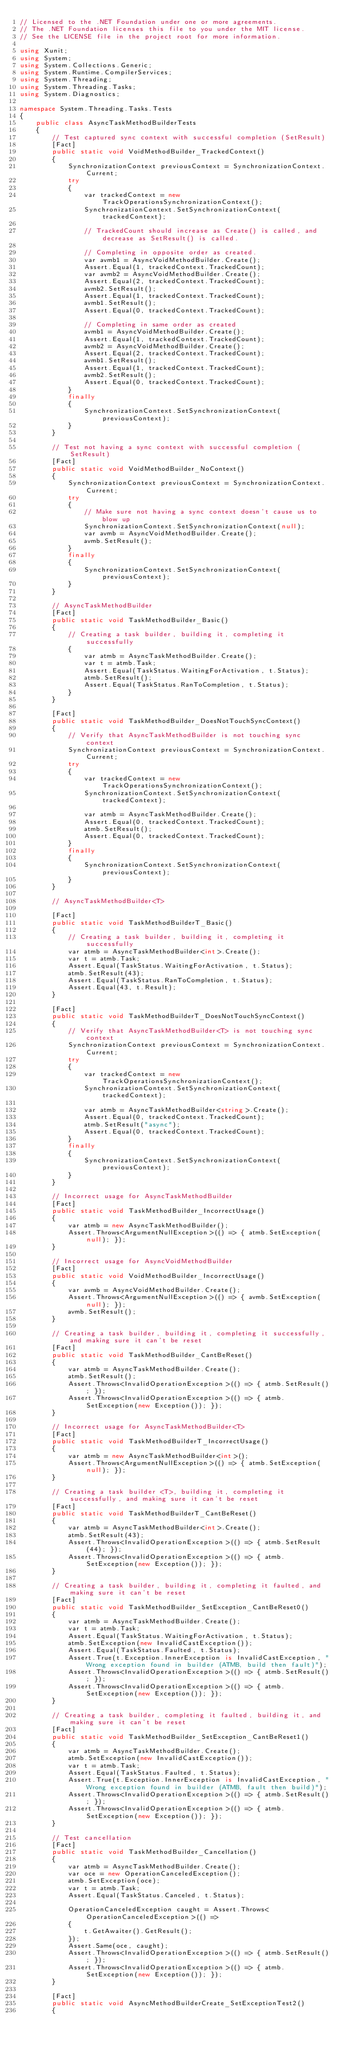Convert code to text. <code><loc_0><loc_0><loc_500><loc_500><_C#_>// Licensed to the .NET Foundation under one or more agreements.
// The .NET Foundation licenses this file to you under the MIT license.
// See the LICENSE file in the project root for more information.

using Xunit;
using System;
using System.Collections.Generic;
using System.Runtime.CompilerServices;
using System.Threading;
using System.Threading.Tasks;
using System.Diagnostics;

namespace System.Threading.Tasks.Tests
{
    public class AsyncTaskMethodBuilderTests
    {
        // Test captured sync context with successful completion (SetResult)
        [Fact]
        public static void VoidMethodBuilder_TrackedContext()
        {
            SynchronizationContext previousContext = SynchronizationContext.Current;
            try
            {
                var trackedContext = new TrackOperationsSynchronizationContext();
                SynchronizationContext.SetSynchronizationContext(trackedContext);

                // TrackedCount should increase as Create() is called, and decrease as SetResult() is called.

                // Completing in opposite order as created.
                var avmb1 = AsyncVoidMethodBuilder.Create();
                Assert.Equal(1, trackedContext.TrackedCount);
                var avmb2 = AsyncVoidMethodBuilder.Create();
                Assert.Equal(2, trackedContext.TrackedCount);
                avmb2.SetResult();
                Assert.Equal(1, trackedContext.TrackedCount);
                avmb1.SetResult();
                Assert.Equal(0, trackedContext.TrackedCount);

                // Completing in same order as created
                avmb1 = AsyncVoidMethodBuilder.Create();
                Assert.Equal(1, trackedContext.TrackedCount);
                avmb2 = AsyncVoidMethodBuilder.Create();
                Assert.Equal(2, trackedContext.TrackedCount);
                avmb1.SetResult();
                Assert.Equal(1, trackedContext.TrackedCount);
                avmb2.SetResult();
                Assert.Equal(0, trackedContext.TrackedCount);
            }
            finally
            {
                SynchronizationContext.SetSynchronizationContext(previousContext);
            }
        }

        // Test not having a sync context with successful completion (SetResult)
        [Fact]
        public static void VoidMethodBuilder_NoContext()
        {
            SynchronizationContext previousContext = SynchronizationContext.Current;
            try
            {
                // Make sure not having a sync context doesn't cause us to blow up
                SynchronizationContext.SetSynchronizationContext(null);
                var avmb = AsyncVoidMethodBuilder.Create();
                avmb.SetResult();
            }
            finally
            {
                SynchronizationContext.SetSynchronizationContext(previousContext);
            }
        }

        // AsyncTaskMethodBuilder
        [Fact]
        public static void TaskMethodBuilder_Basic()
        {
            // Creating a task builder, building it, completing it successfully
            {
                var atmb = AsyncTaskMethodBuilder.Create();
                var t = atmb.Task;
                Assert.Equal(TaskStatus.WaitingForActivation, t.Status);
                atmb.SetResult();
                Assert.Equal(TaskStatus.RanToCompletion, t.Status);
            }
        }

        [Fact]
        public static void TaskMethodBuilder_DoesNotTouchSyncContext()
        {
            // Verify that AsyncTaskMethodBuilder is not touching sync context
            SynchronizationContext previousContext = SynchronizationContext.Current;
            try
            {
                var trackedContext = new TrackOperationsSynchronizationContext();
                SynchronizationContext.SetSynchronizationContext(trackedContext);

                var atmb = AsyncTaskMethodBuilder.Create();
                Assert.Equal(0, trackedContext.TrackedCount);
                atmb.SetResult();
                Assert.Equal(0, trackedContext.TrackedCount);
            }
            finally
            {
                SynchronizationContext.SetSynchronizationContext(previousContext);
            }
        }

        // AsyncTaskMethodBuilder<T>

        [Fact]
        public static void TaskMethodBuilderT_Basic()
        {
            // Creating a task builder, building it, completing it successfully
            var atmb = AsyncTaskMethodBuilder<int>.Create();
            var t = atmb.Task;
            Assert.Equal(TaskStatus.WaitingForActivation, t.Status);
            atmb.SetResult(43);
            Assert.Equal(TaskStatus.RanToCompletion, t.Status);
            Assert.Equal(43, t.Result);
        }

        [Fact]
        public static void TaskMethodBuilderT_DoesNotTouchSyncContext()
        {
            // Verify that AsyncTaskMethodBuilder<T> is not touching sync context
            SynchronizationContext previousContext = SynchronizationContext.Current;
            try
            {
                var trackedContext = new TrackOperationsSynchronizationContext();
                SynchronizationContext.SetSynchronizationContext(trackedContext);

                var atmb = AsyncTaskMethodBuilder<string>.Create();
                Assert.Equal(0, trackedContext.TrackedCount);
                atmb.SetResult("async");
                Assert.Equal(0, trackedContext.TrackedCount);
            }
            finally
            {
                SynchronizationContext.SetSynchronizationContext(previousContext);
            }
        }

        // Incorrect usage for AsyncTaskMethodBuilder
        [Fact]
        public static void TaskMethodBuilder_IncorrectUsage()
        {
            var atmb = new AsyncTaskMethodBuilder();
            Assert.Throws<ArgumentNullException>(() => { atmb.SetException(null); });
        }

        // Incorrect usage for AsyncVoidMethodBuilder
        [Fact]
        public static void VoidMethodBuilder_IncorrectUsage()
        {
            var avmb = AsyncVoidMethodBuilder.Create();
            Assert.Throws<ArgumentNullException>(() => { avmb.SetException(null); });
            avmb.SetResult();
        }

        // Creating a task builder, building it, completing it successfully, and making sure it can't be reset
        [Fact]
        public static void TaskMethodBuilder_CantBeReset()
        {
            var atmb = AsyncTaskMethodBuilder.Create();
            atmb.SetResult();
            Assert.Throws<InvalidOperationException>(() => { atmb.SetResult(); });
            Assert.Throws<InvalidOperationException>(() => { atmb.SetException(new Exception()); });
        }

        // Incorrect usage for AsyncTaskMethodBuilder<T>
        [Fact]
        public static void TaskMethodBuilderT_IncorrectUsage()
        {
            var atmb = new AsyncTaskMethodBuilder<int>();
            Assert.Throws<ArgumentNullException>(() => { atmb.SetException(null); });
        }

        // Creating a task builder <T>, building it, completing it successfully, and making sure it can't be reset
        [Fact]
        public static void TaskMethodBuilderT_CantBeReset()
        {
            var atmb = AsyncTaskMethodBuilder<int>.Create();
            atmb.SetResult(43);
            Assert.Throws<InvalidOperationException>(() => { atmb.SetResult(44); });
            Assert.Throws<InvalidOperationException>(() => { atmb.SetException(new Exception()); });
        }

        // Creating a task builder, building it, completing it faulted, and making sure it can't be reset
        [Fact]
        public static void TaskMethodBuilder_SetException_CantBeReset0()
        {
            var atmb = AsyncTaskMethodBuilder.Create();
            var t = atmb.Task;
            Assert.Equal(TaskStatus.WaitingForActivation, t.Status);
            atmb.SetException(new InvalidCastException());
            Assert.Equal(TaskStatus.Faulted, t.Status);
            Assert.True(t.Exception.InnerException is InvalidCastException, "Wrong exception found in builder (ATMB, build then fault)");
            Assert.Throws<InvalidOperationException>(() => { atmb.SetResult(); });
            Assert.Throws<InvalidOperationException>(() => { atmb.SetException(new Exception()); });
        }

        // Creating a task builder, completing it faulted, building it, and making sure it can't be reset
        [Fact]
        public static void TaskMethodBuilder_SetException_CantBeReset1()
        {
            var atmb = AsyncTaskMethodBuilder.Create();
            atmb.SetException(new InvalidCastException());
            var t = atmb.Task;
            Assert.Equal(TaskStatus.Faulted, t.Status);
            Assert.True(t.Exception.InnerException is InvalidCastException, "Wrong exception found in builder (ATMB, fault then build)");
            Assert.Throws<InvalidOperationException>(() => { atmb.SetResult(); });
            Assert.Throws<InvalidOperationException>(() => { atmb.SetException(new Exception()); });
        }

        // Test cancellation
        [Fact]
        public static void TaskMethodBuilder_Cancellation()
        {
            var atmb = AsyncTaskMethodBuilder.Create();
            var oce = new OperationCanceledException();
            atmb.SetException(oce);
            var t = atmb.Task;
            Assert.Equal(TaskStatus.Canceled, t.Status);

            OperationCanceledException caught = Assert.Throws<OperationCanceledException>(() =>
            {
                t.GetAwaiter().GetResult();
            });
            Assert.Same(oce, caught);
            Assert.Throws<InvalidOperationException>(() => { atmb.SetResult(); });
            Assert.Throws<InvalidOperationException>(() => { atmb.SetException(new Exception()); });
        }

        [Fact]
        public static void AsyncMethodBuilderCreate_SetExceptionTest2()
        {</code> 